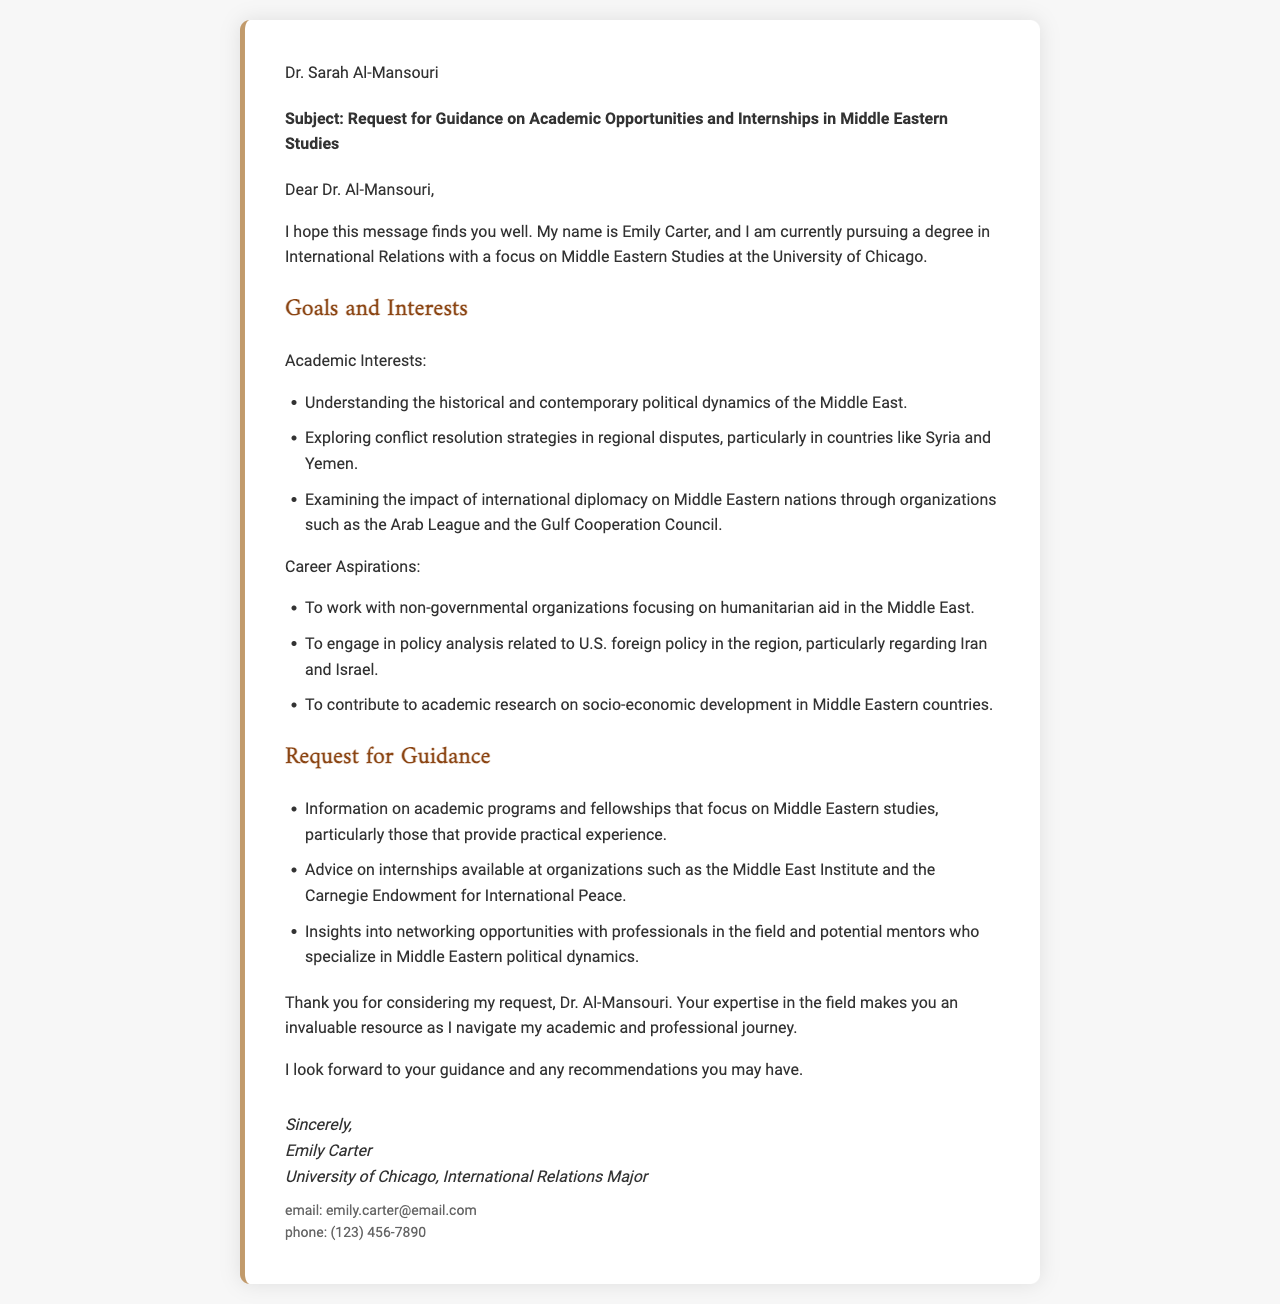What is the name of the sender? The sender of the letter is Emily Carter, as mentioned at the end of the document.
Answer: Emily Carter What is the subject of the letter? The subject line of the letter states the main topic of the communication, which is about seeking guidance on academic opportunities and internships.
Answer: Request for Guidance on Academic Opportunities and Internships in Middle Eastern Studies What university is the sender attending? The document explicitly mentions that Emily Carter is studying at the University of Chicago.
Answer: University of Chicago Which organizations are mentioned as potential internship opportunities? The letter lists specific organizations where Emily seeks internships, highlighting those relevant to Middle Eastern studies.
Answer: Middle East Institute and Carnegie Endowment for International Peace List one of Emily's academic interests. The document outlines several of Emily's academic interests regarding the Middle East, and one specific interest can be provided as an example.
Answer: Understanding the historical and contemporary political dynamics of the Middle East How many career aspirations does Emily outline? The document presents a list of career aspirations, and the total number can be counted from that section.
Answer: Three What is Emily's email address? The contact information section of the letter provides Emily’s email address.
Answer: emily.carter@email.com What does Emily hope to achieve by engaging in policy analysis? The letter outlines Emily's desire to focus on a specific aspect of U.S. foreign policy, indicating her professional objectives.
Answer: regarding Iran and Israel What kind of professionals does Emily seek to connect with? The letter specifically mentions Emily's desire to network with certain types of professionals, indicating her mentorship interests.
Answer: professionals in the field 